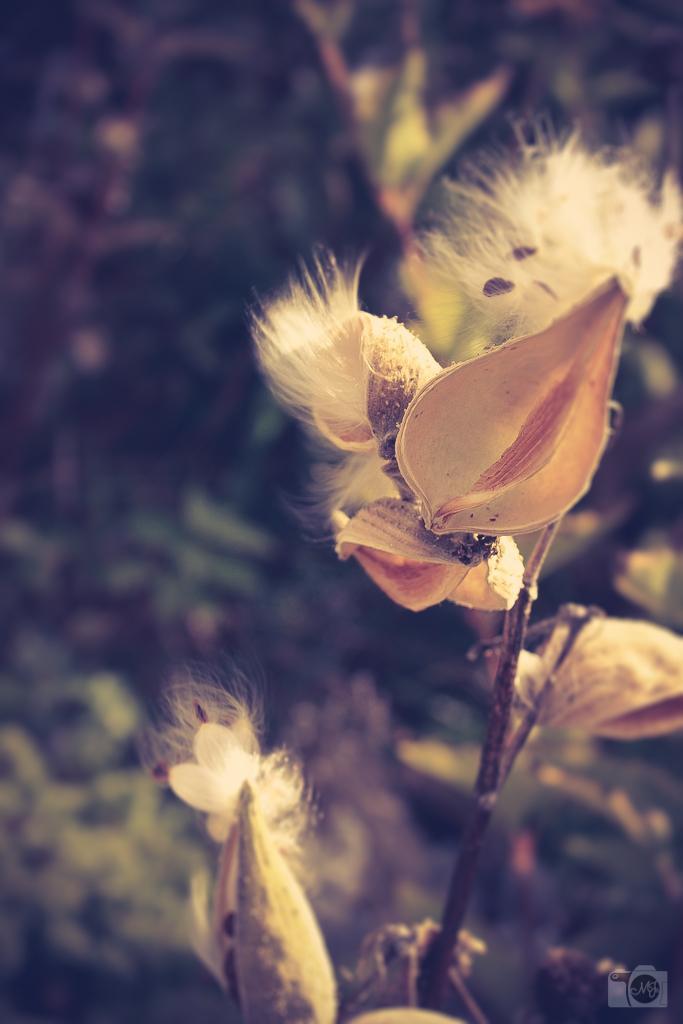Can you describe this image briefly? In the image in the center, we can see one plant and flowers. 